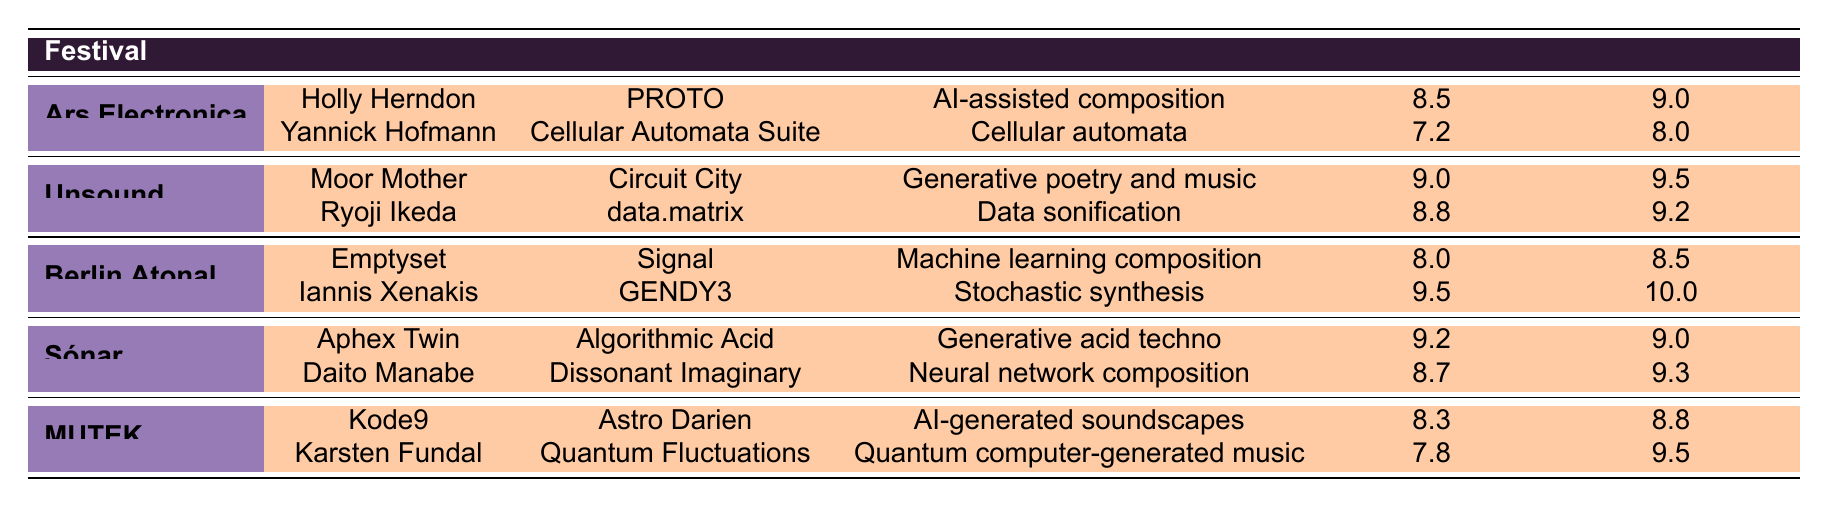What was the critical rating of Moor Mother's piece "Circuit City"? The critical rating for Moor Mother's piece "Circuit City" can be found in the row where it is mentioned. The value listed under "Critical Rating" for this piece is 9.0.
Answer: 9.0 Which algorithm type had the highest innovation score? The highest innovation score can be found by comparing the innovation scores listed in the table. The piece "GENDY3" by Iannis Xenakis has an innovation score of 10, which is the highest among all listed performances.
Answer: Stochastic synthesis Did any performance at the Berlin Atonal festival have a critical rating above 9? By examining the critical ratings in the Berlin Atonal section, Iannis Xenakis's piece "GENDY3" has a critical rating of 9.5, which is indeed above 9.
Answer: Yes What is the average critical rating for the performances at Sónar? To find the average critical rating for the Sónar performances, we take the ratings of both pieces: 9.2 and 8.7. Adding these gives 17.9, and then dividing by 2 gives an average of 8.95.
Answer: 8.95 Which performances had a mixed audience reception? The audience reception can be checked in the respective rows of the table. Both "Cellular Automata Suite" by Yannick Hofmann and "Quantum Fluctuations" by Karsten Fundal are marked as having mixed audience receptions.
Answer: Cellular Automata Suite, Quantum Fluctuations What is the difference between the innovation score of "Circuit City" and "Dissonant Imaginary"? The innovation scores for "Circuit City" and "Dissonant Imaginary" are 9.5 and 9.3 respectively. The difference can be calculated as 9.5 - 9.3, which equals 0.2.
Answer: 0.2 Which festival featured two performances with critical ratings above 8.5? Looking through the festival performances, both the Unsound and Sónar festivals had performances with critical ratings above 8.5. Specifically, Unsound had scores of 9.0 and 8.8, while Sónar had scores of 9.2 and 8.7.
Answer: Unsound, Sónar What was the algorithm type for the performance with the lowest critical rating? The lowest critical rating in the table is 7.2, which corresponds to "Cellular Automata Suite" by Yannick Hofmann. The algorithm type for this performance is "Cellular automata".
Answer: Cellular automata 